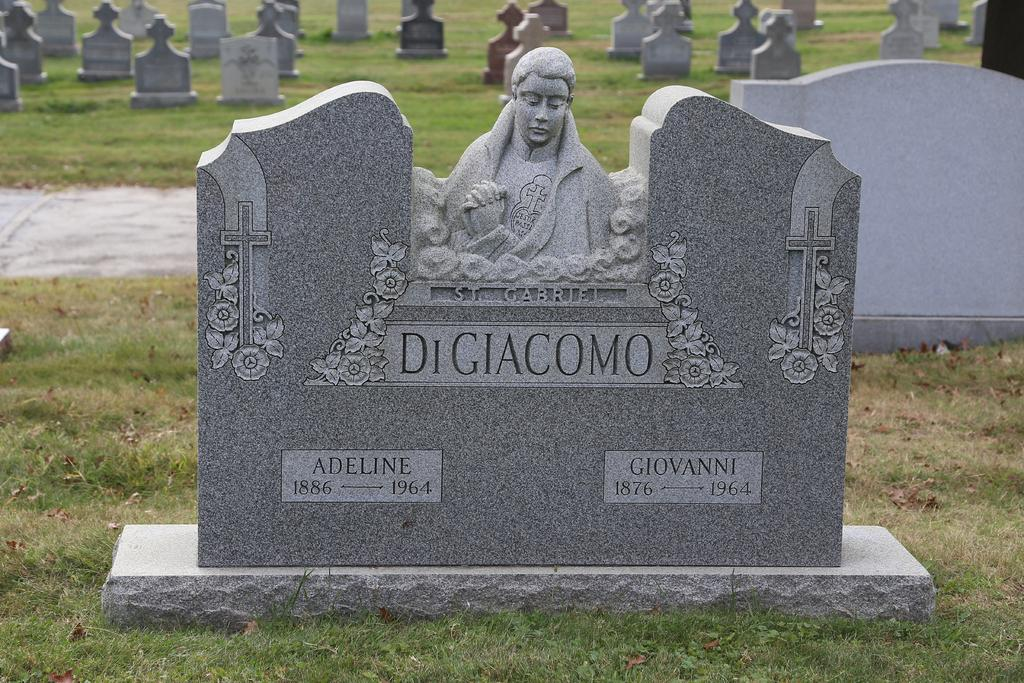What type of structures can be seen in the image? There are graves in the image. What other object is present in the image besides the graves? There is a sculpture in the image. What religious symbol is visible in the image? Cross symbols are present in the image. Can you read any text in the image? There are texts on a grave in the image. What type of vegetation can be seen in the image? There is grass visible in the image. How many yams are buried under the fifth grave in the image? There are no yams mentioned or visible in the image, and there is no reference to a fifth grave. 